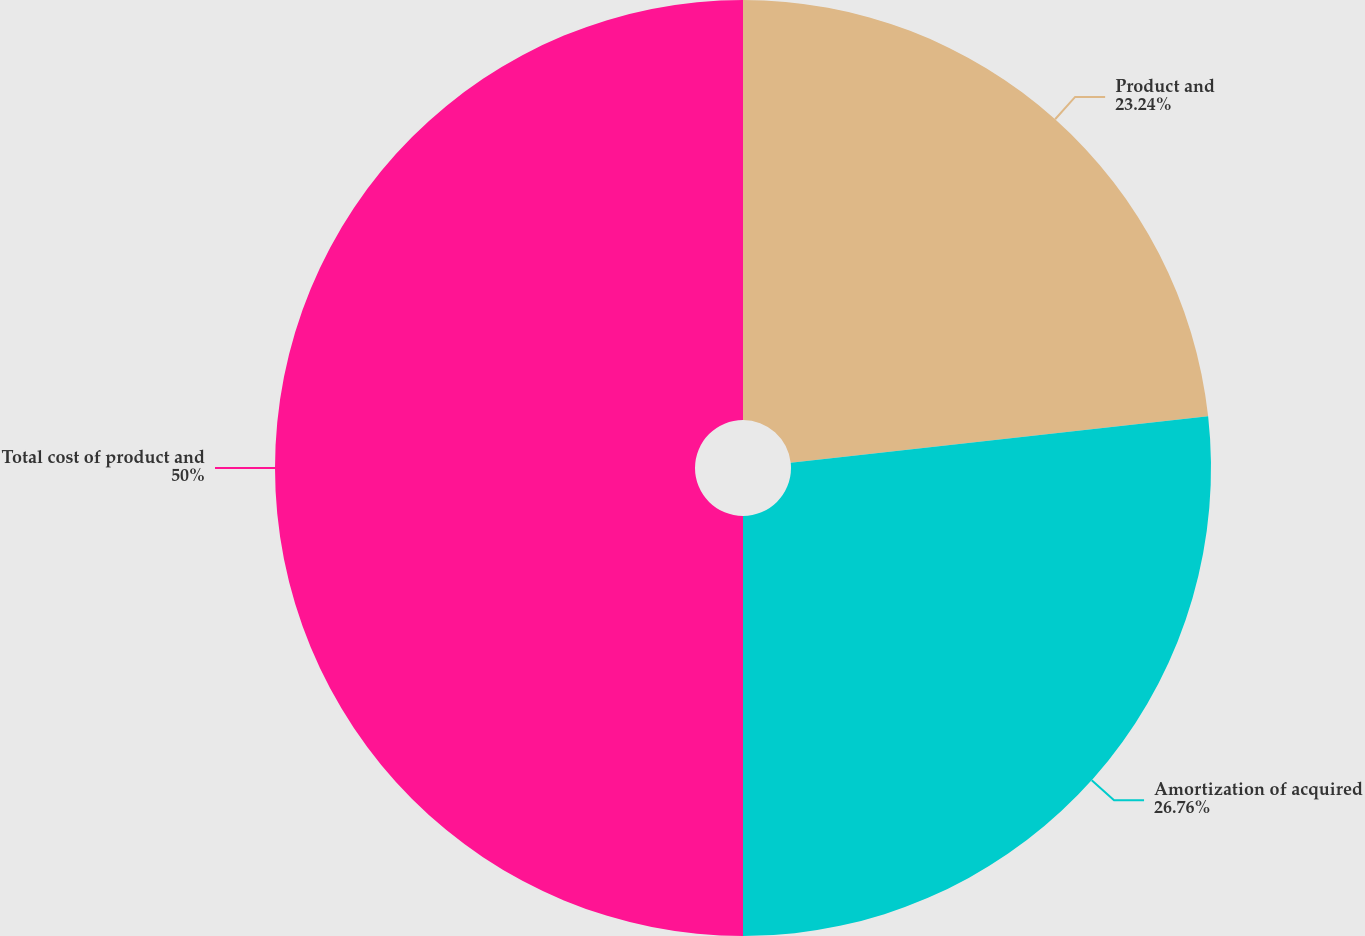Convert chart to OTSL. <chart><loc_0><loc_0><loc_500><loc_500><pie_chart><fcel>Product and<fcel>Amortization of acquired<fcel>Total cost of product and<nl><fcel>23.24%<fcel>26.76%<fcel>50.0%<nl></chart> 